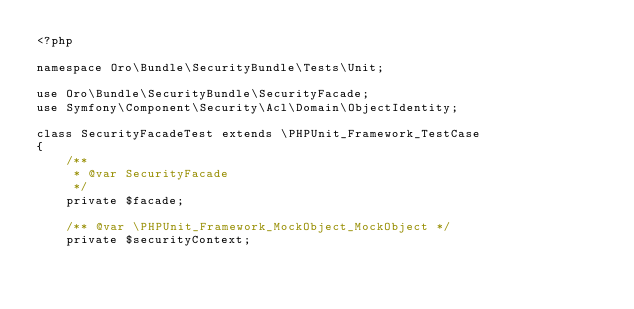<code> <loc_0><loc_0><loc_500><loc_500><_PHP_><?php

namespace Oro\Bundle\SecurityBundle\Tests\Unit;

use Oro\Bundle\SecurityBundle\SecurityFacade;
use Symfony\Component\Security\Acl\Domain\ObjectIdentity;

class SecurityFacadeTest extends \PHPUnit_Framework_TestCase
{
    /**
     * @var SecurityFacade
     */
    private $facade;

    /** @var \PHPUnit_Framework_MockObject_MockObject */
    private $securityContext;
</code> 